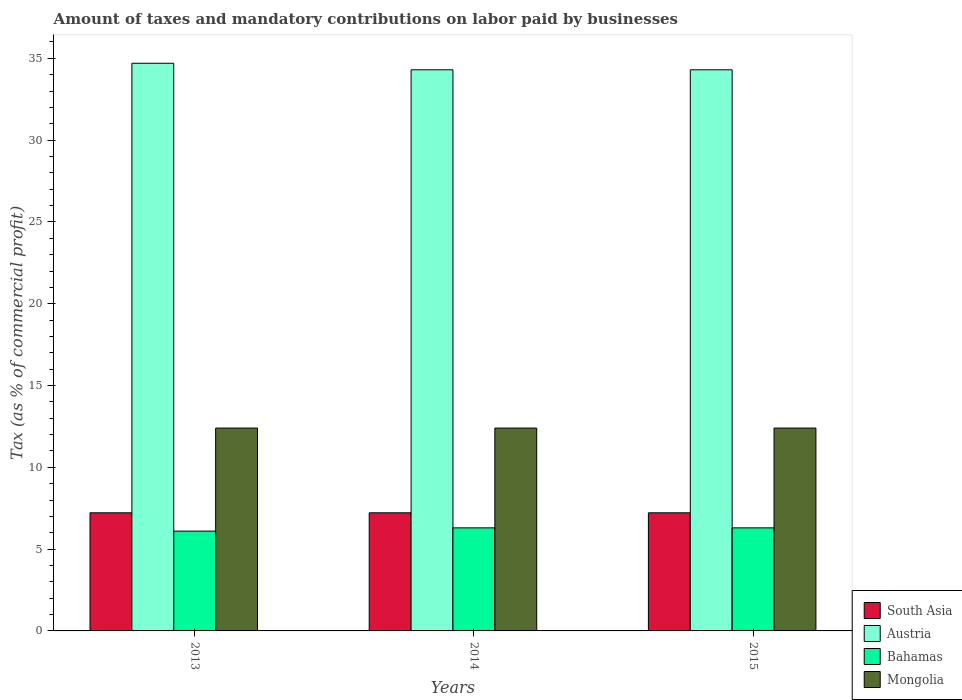How many different coloured bars are there?
Make the answer very short. 4. How many groups of bars are there?
Provide a short and direct response. 3. Are the number of bars per tick equal to the number of legend labels?
Give a very brief answer. Yes. Are the number of bars on each tick of the X-axis equal?
Your answer should be very brief. Yes. How many bars are there on the 1st tick from the left?
Your answer should be very brief. 4. What is the label of the 3rd group of bars from the left?
Give a very brief answer. 2015. What is the percentage of taxes paid by businesses in Austria in 2014?
Make the answer very short. 34.3. Across all years, what is the maximum percentage of taxes paid by businesses in South Asia?
Your answer should be compact. 7.22. Across all years, what is the minimum percentage of taxes paid by businesses in South Asia?
Ensure brevity in your answer.  7.22. What is the total percentage of taxes paid by businesses in Austria in the graph?
Give a very brief answer. 103.3. What is the difference between the percentage of taxes paid by businesses in Austria in 2013 and that in 2015?
Your answer should be very brief. 0.4. What is the difference between the percentage of taxes paid by businesses in Austria in 2015 and the percentage of taxes paid by businesses in Mongolia in 2013?
Your answer should be compact. 21.9. What is the average percentage of taxes paid by businesses in South Asia per year?
Your answer should be compact. 7.22. In the year 2015, what is the difference between the percentage of taxes paid by businesses in Austria and percentage of taxes paid by businesses in Bahamas?
Ensure brevity in your answer.  28. What is the ratio of the percentage of taxes paid by businesses in Austria in 2013 to that in 2015?
Give a very brief answer. 1.01. What is the difference between the highest and the second highest percentage of taxes paid by businesses in South Asia?
Your response must be concise. 0. What is the difference between the highest and the lowest percentage of taxes paid by businesses in Bahamas?
Your answer should be very brief. 0.2. Is the sum of the percentage of taxes paid by businesses in Austria in 2013 and 2014 greater than the maximum percentage of taxes paid by businesses in Bahamas across all years?
Your answer should be compact. Yes. What does the 4th bar from the left in 2015 represents?
Keep it short and to the point. Mongolia. Is it the case that in every year, the sum of the percentage of taxes paid by businesses in Mongolia and percentage of taxes paid by businesses in Austria is greater than the percentage of taxes paid by businesses in South Asia?
Keep it short and to the point. Yes. How many years are there in the graph?
Your answer should be very brief. 3. What is the difference between two consecutive major ticks on the Y-axis?
Keep it short and to the point. 5. Are the values on the major ticks of Y-axis written in scientific E-notation?
Give a very brief answer. No. Does the graph contain grids?
Your answer should be compact. No. Where does the legend appear in the graph?
Your answer should be compact. Bottom right. How many legend labels are there?
Offer a very short reply. 4. What is the title of the graph?
Your answer should be compact. Amount of taxes and mandatory contributions on labor paid by businesses. Does "Europe(all income levels)" appear as one of the legend labels in the graph?
Provide a succinct answer. No. What is the label or title of the X-axis?
Give a very brief answer. Years. What is the label or title of the Y-axis?
Offer a terse response. Tax (as % of commercial profit). What is the Tax (as % of commercial profit) in South Asia in 2013?
Provide a short and direct response. 7.22. What is the Tax (as % of commercial profit) of Austria in 2013?
Provide a succinct answer. 34.7. What is the Tax (as % of commercial profit) in Bahamas in 2013?
Your answer should be very brief. 6.1. What is the Tax (as % of commercial profit) of South Asia in 2014?
Offer a very short reply. 7.22. What is the Tax (as % of commercial profit) in Austria in 2014?
Offer a very short reply. 34.3. What is the Tax (as % of commercial profit) in Bahamas in 2014?
Make the answer very short. 6.3. What is the Tax (as % of commercial profit) in South Asia in 2015?
Offer a very short reply. 7.22. What is the Tax (as % of commercial profit) of Austria in 2015?
Offer a terse response. 34.3. What is the Tax (as % of commercial profit) of Bahamas in 2015?
Provide a short and direct response. 6.3. Across all years, what is the maximum Tax (as % of commercial profit) in South Asia?
Give a very brief answer. 7.22. Across all years, what is the maximum Tax (as % of commercial profit) in Austria?
Your answer should be very brief. 34.7. Across all years, what is the maximum Tax (as % of commercial profit) in Mongolia?
Offer a terse response. 12.4. Across all years, what is the minimum Tax (as % of commercial profit) of South Asia?
Provide a succinct answer. 7.22. Across all years, what is the minimum Tax (as % of commercial profit) of Austria?
Make the answer very short. 34.3. Across all years, what is the minimum Tax (as % of commercial profit) of Bahamas?
Provide a succinct answer. 6.1. Across all years, what is the minimum Tax (as % of commercial profit) in Mongolia?
Offer a terse response. 12.4. What is the total Tax (as % of commercial profit) in South Asia in the graph?
Your answer should be compact. 21.66. What is the total Tax (as % of commercial profit) of Austria in the graph?
Provide a short and direct response. 103.3. What is the total Tax (as % of commercial profit) of Bahamas in the graph?
Your response must be concise. 18.7. What is the total Tax (as % of commercial profit) of Mongolia in the graph?
Your answer should be very brief. 37.2. What is the difference between the Tax (as % of commercial profit) in South Asia in 2013 and that in 2014?
Make the answer very short. 0. What is the difference between the Tax (as % of commercial profit) of Austria in 2013 and that in 2014?
Your answer should be very brief. 0.4. What is the difference between the Tax (as % of commercial profit) of Austria in 2013 and that in 2015?
Provide a short and direct response. 0.4. What is the difference between the Tax (as % of commercial profit) of Mongolia in 2013 and that in 2015?
Offer a terse response. 0. What is the difference between the Tax (as % of commercial profit) in Bahamas in 2014 and that in 2015?
Keep it short and to the point. 0. What is the difference between the Tax (as % of commercial profit) of South Asia in 2013 and the Tax (as % of commercial profit) of Austria in 2014?
Provide a succinct answer. -27.08. What is the difference between the Tax (as % of commercial profit) of South Asia in 2013 and the Tax (as % of commercial profit) of Mongolia in 2014?
Offer a very short reply. -5.18. What is the difference between the Tax (as % of commercial profit) of Austria in 2013 and the Tax (as % of commercial profit) of Bahamas in 2014?
Provide a short and direct response. 28.4. What is the difference between the Tax (as % of commercial profit) of Austria in 2013 and the Tax (as % of commercial profit) of Mongolia in 2014?
Provide a succinct answer. 22.3. What is the difference between the Tax (as % of commercial profit) of South Asia in 2013 and the Tax (as % of commercial profit) of Austria in 2015?
Your answer should be compact. -27.08. What is the difference between the Tax (as % of commercial profit) in South Asia in 2013 and the Tax (as % of commercial profit) in Bahamas in 2015?
Offer a very short reply. 0.92. What is the difference between the Tax (as % of commercial profit) of South Asia in 2013 and the Tax (as % of commercial profit) of Mongolia in 2015?
Offer a terse response. -5.18. What is the difference between the Tax (as % of commercial profit) of Austria in 2013 and the Tax (as % of commercial profit) of Bahamas in 2015?
Your answer should be very brief. 28.4. What is the difference between the Tax (as % of commercial profit) in Austria in 2013 and the Tax (as % of commercial profit) in Mongolia in 2015?
Ensure brevity in your answer.  22.3. What is the difference between the Tax (as % of commercial profit) of South Asia in 2014 and the Tax (as % of commercial profit) of Austria in 2015?
Provide a succinct answer. -27.08. What is the difference between the Tax (as % of commercial profit) in South Asia in 2014 and the Tax (as % of commercial profit) in Bahamas in 2015?
Offer a terse response. 0.92. What is the difference between the Tax (as % of commercial profit) in South Asia in 2014 and the Tax (as % of commercial profit) in Mongolia in 2015?
Keep it short and to the point. -5.18. What is the difference between the Tax (as % of commercial profit) of Austria in 2014 and the Tax (as % of commercial profit) of Bahamas in 2015?
Give a very brief answer. 28. What is the difference between the Tax (as % of commercial profit) in Austria in 2014 and the Tax (as % of commercial profit) in Mongolia in 2015?
Offer a terse response. 21.9. What is the average Tax (as % of commercial profit) of South Asia per year?
Your answer should be compact. 7.22. What is the average Tax (as % of commercial profit) in Austria per year?
Your answer should be very brief. 34.43. What is the average Tax (as % of commercial profit) of Bahamas per year?
Provide a short and direct response. 6.23. In the year 2013, what is the difference between the Tax (as % of commercial profit) in South Asia and Tax (as % of commercial profit) in Austria?
Offer a very short reply. -27.48. In the year 2013, what is the difference between the Tax (as % of commercial profit) in South Asia and Tax (as % of commercial profit) in Bahamas?
Ensure brevity in your answer.  1.12. In the year 2013, what is the difference between the Tax (as % of commercial profit) in South Asia and Tax (as % of commercial profit) in Mongolia?
Give a very brief answer. -5.18. In the year 2013, what is the difference between the Tax (as % of commercial profit) of Austria and Tax (as % of commercial profit) of Bahamas?
Offer a very short reply. 28.6. In the year 2013, what is the difference between the Tax (as % of commercial profit) of Austria and Tax (as % of commercial profit) of Mongolia?
Offer a very short reply. 22.3. In the year 2014, what is the difference between the Tax (as % of commercial profit) of South Asia and Tax (as % of commercial profit) of Austria?
Your response must be concise. -27.08. In the year 2014, what is the difference between the Tax (as % of commercial profit) of South Asia and Tax (as % of commercial profit) of Bahamas?
Your response must be concise. 0.92. In the year 2014, what is the difference between the Tax (as % of commercial profit) in South Asia and Tax (as % of commercial profit) in Mongolia?
Your answer should be very brief. -5.18. In the year 2014, what is the difference between the Tax (as % of commercial profit) in Austria and Tax (as % of commercial profit) in Bahamas?
Make the answer very short. 28. In the year 2014, what is the difference between the Tax (as % of commercial profit) in Austria and Tax (as % of commercial profit) in Mongolia?
Keep it short and to the point. 21.9. In the year 2015, what is the difference between the Tax (as % of commercial profit) in South Asia and Tax (as % of commercial profit) in Austria?
Your response must be concise. -27.08. In the year 2015, what is the difference between the Tax (as % of commercial profit) in South Asia and Tax (as % of commercial profit) in Bahamas?
Keep it short and to the point. 0.92. In the year 2015, what is the difference between the Tax (as % of commercial profit) of South Asia and Tax (as % of commercial profit) of Mongolia?
Ensure brevity in your answer.  -5.18. In the year 2015, what is the difference between the Tax (as % of commercial profit) in Austria and Tax (as % of commercial profit) in Bahamas?
Provide a succinct answer. 28. In the year 2015, what is the difference between the Tax (as % of commercial profit) in Austria and Tax (as % of commercial profit) in Mongolia?
Your answer should be very brief. 21.9. In the year 2015, what is the difference between the Tax (as % of commercial profit) in Bahamas and Tax (as % of commercial profit) in Mongolia?
Make the answer very short. -6.1. What is the ratio of the Tax (as % of commercial profit) of Austria in 2013 to that in 2014?
Your answer should be very brief. 1.01. What is the ratio of the Tax (as % of commercial profit) in Bahamas in 2013 to that in 2014?
Give a very brief answer. 0.97. What is the ratio of the Tax (as % of commercial profit) of Mongolia in 2013 to that in 2014?
Your answer should be compact. 1. What is the ratio of the Tax (as % of commercial profit) in South Asia in 2013 to that in 2015?
Provide a succinct answer. 1. What is the ratio of the Tax (as % of commercial profit) of Austria in 2013 to that in 2015?
Ensure brevity in your answer.  1.01. What is the ratio of the Tax (as % of commercial profit) in Bahamas in 2013 to that in 2015?
Give a very brief answer. 0.97. What is the ratio of the Tax (as % of commercial profit) in Austria in 2014 to that in 2015?
Offer a terse response. 1. What is the difference between the highest and the second highest Tax (as % of commercial profit) in South Asia?
Keep it short and to the point. 0. What is the difference between the highest and the second highest Tax (as % of commercial profit) in Austria?
Keep it short and to the point. 0.4. What is the difference between the highest and the second highest Tax (as % of commercial profit) in Bahamas?
Offer a very short reply. 0. What is the difference between the highest and the second highest Tax (as % of commercial profit) of Mongolia?
Make the answer very short. 0. What is the difference between the highest and the lowest Tax (as % of commercial profit) in Bahamas?
Provide a succinct answer. 0.2. 